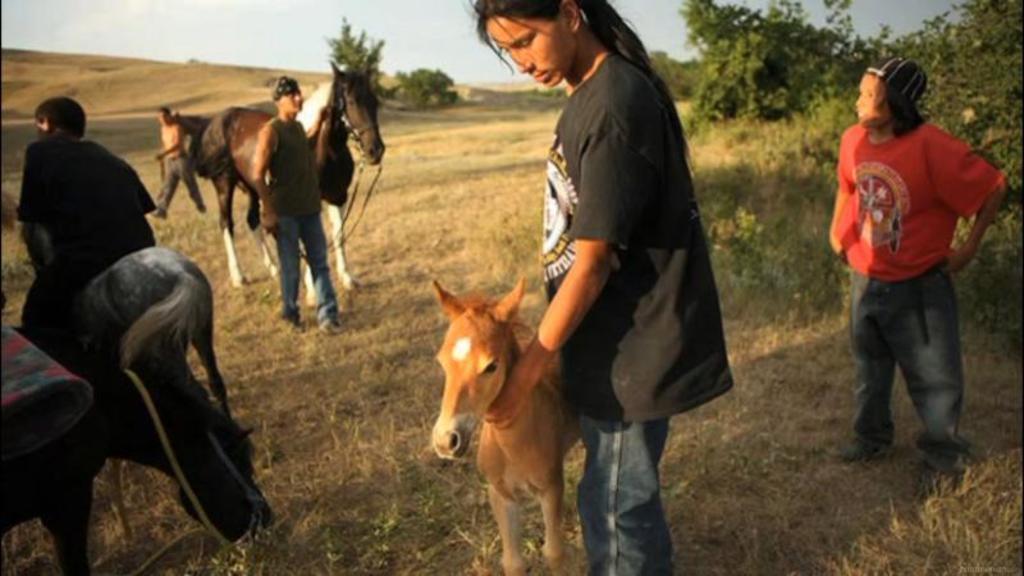Please provide a concise description of this image. this picture shows people standing and a man riding horse on the man holding horse with his hands and a woman holding a pony and we see few plants on the side 